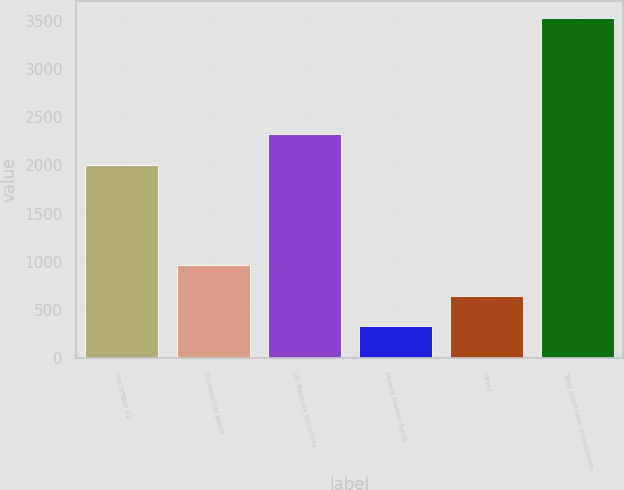Convert chart to OTSL. <chart><loc_0><loc_0><loc_500><loc_500><bar_chart><fcel>December 31<fcel>Commercial paper<fcel>US Treasury securities<fcel>Money market funds<fcel>Other<fcel>Total short term investments<nl><fcel>2008<fcel>970<fcel>2328.5<fcel>329<fcel>649.5<fcel>3534<nl></chart> 